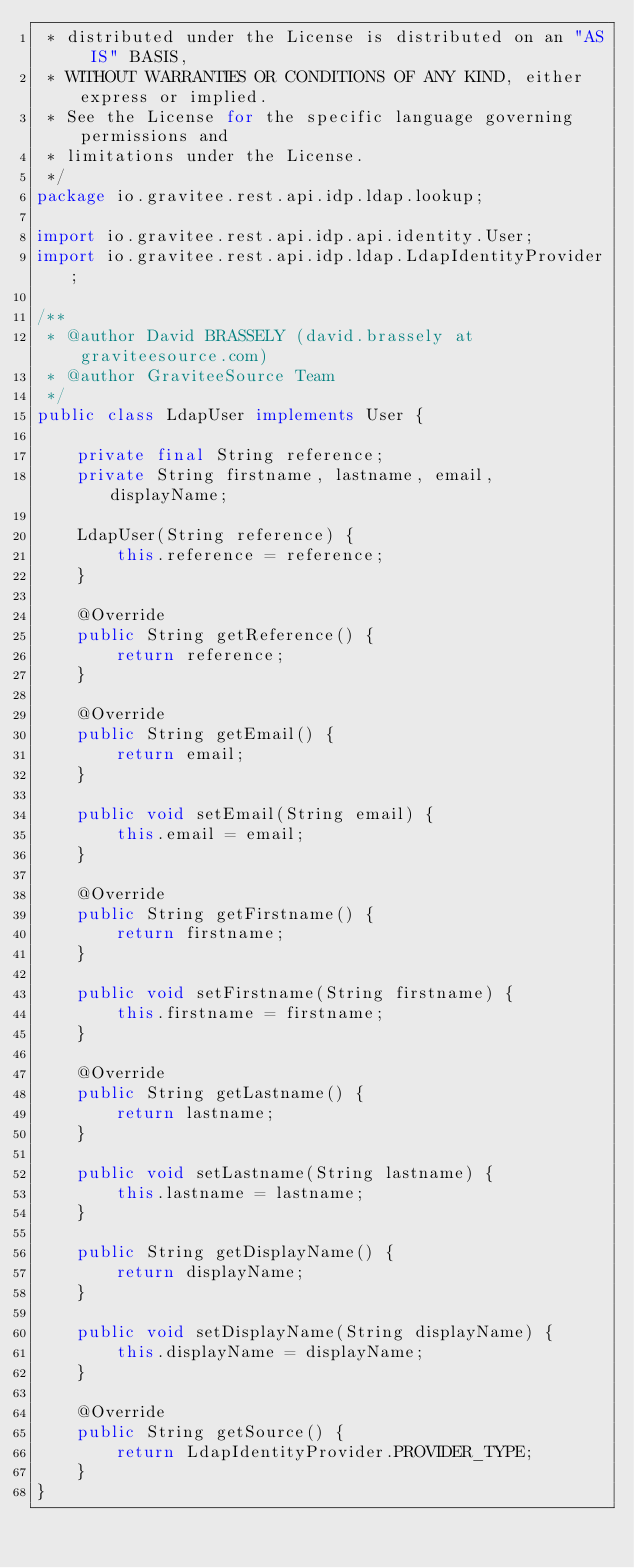Convert code to text. <code><loc_0><loc_0><loc_500><loc_500><_Java_> * distributed under the License is distributed on an "AS IS" BASIS,
 * WITHOUT WARRANTIES OR CONDITIONS OF ANY KIND, either express or implied.
 * See the License for the specific language governing permissions and
 * limitations under the License.
 */
package io.gravitee.rest.api.idp.ldap.lookup;

import io.gravitee.rest.api.idp.api.identity.User;
import io.gravitee.rest.api.idp.ldap.LdapIdentityProvider;

/**
 * @author David BRASSELY (david.brassely at graviteesource.com)
 * @author GraviteeSource Team
 */
public class LdapUser implements User {

    private final String reference;
    private String firstname, lastname, email, displayName;

    LdapUser(String reference) {
        this.reference = reference;
    }

    @Override
    public String getReference() {
        return reference;
    }

    @Override
    public String getEmail() {
        return email;
    }

    public void setEmail(String email) {
        this.email = email;
    }

    @Override
    public String getFirstname() {
        return firstname;
    }

    public void setFirstname(String firstname) {
        this.firstname = firstname;
    }

    @Override
    public String getLastname() {
        return lastname;
    }

    public void setLastname(String lastname) {
        this.lastname = lastname;
    }

    public String getDisplayName() {
        return displayName;
    }

    public void setDisplayName(String displayName) {
        this.displayName = displayName;
    }

    @Override
    public String getSource() {
        return LdapIdentityProvider.PROVIDER_TYPE;
    }
}</code> 